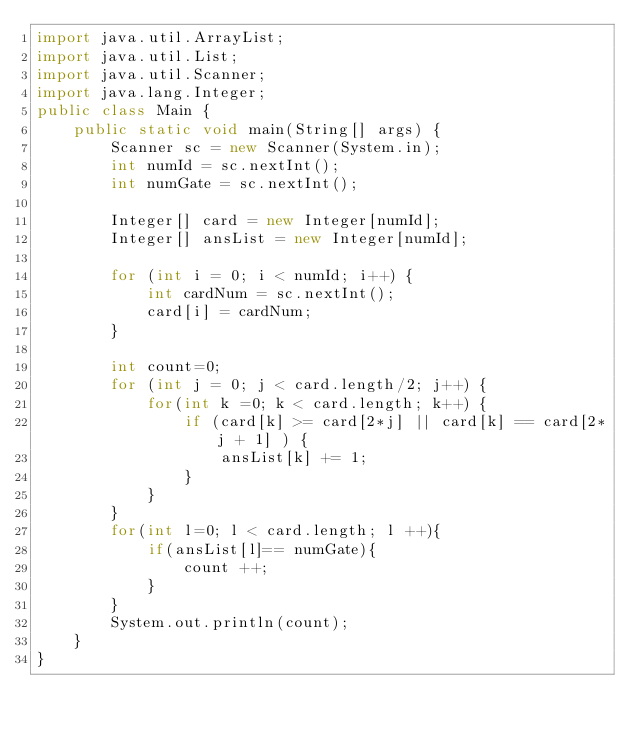Convert code to text. <code><loc_0><loc_0><loc_500><loc_500><_Java_>import java.util.ArrayList;
import java.util.List;
import java.util.Scanner;
import java.lang.Integer;
public class Main {
    public static void main(String[] args) {
        Scanner sc = new Scanner(System.in);
        int numId = sc.nextInt();
        int numGate = sc.nextInt();

        Integer[] card = new Integer[numId];
        Integer[] ansList = new Integer[numId];

        for (int i = 0; i < numId; i++) {
            int cardNum = sc.nextInt();
            card[i] = cardNum;
        }

        int count=0;
        for (int j = 0; j < card.length/2; j++) {
            for(int k =0; k < card.length; k++) {
                if (card[k] >= card[2*j] || card[k] == card[2*j + 1] ) {
                    ansList[k] += 1;
                }
            }
        }
        for(int l=0; l < card.length; l ++){
            if(ansList[l]== numGate){
                count ++;
            }
        }
        System.out.println(count);
    }
}</code> 